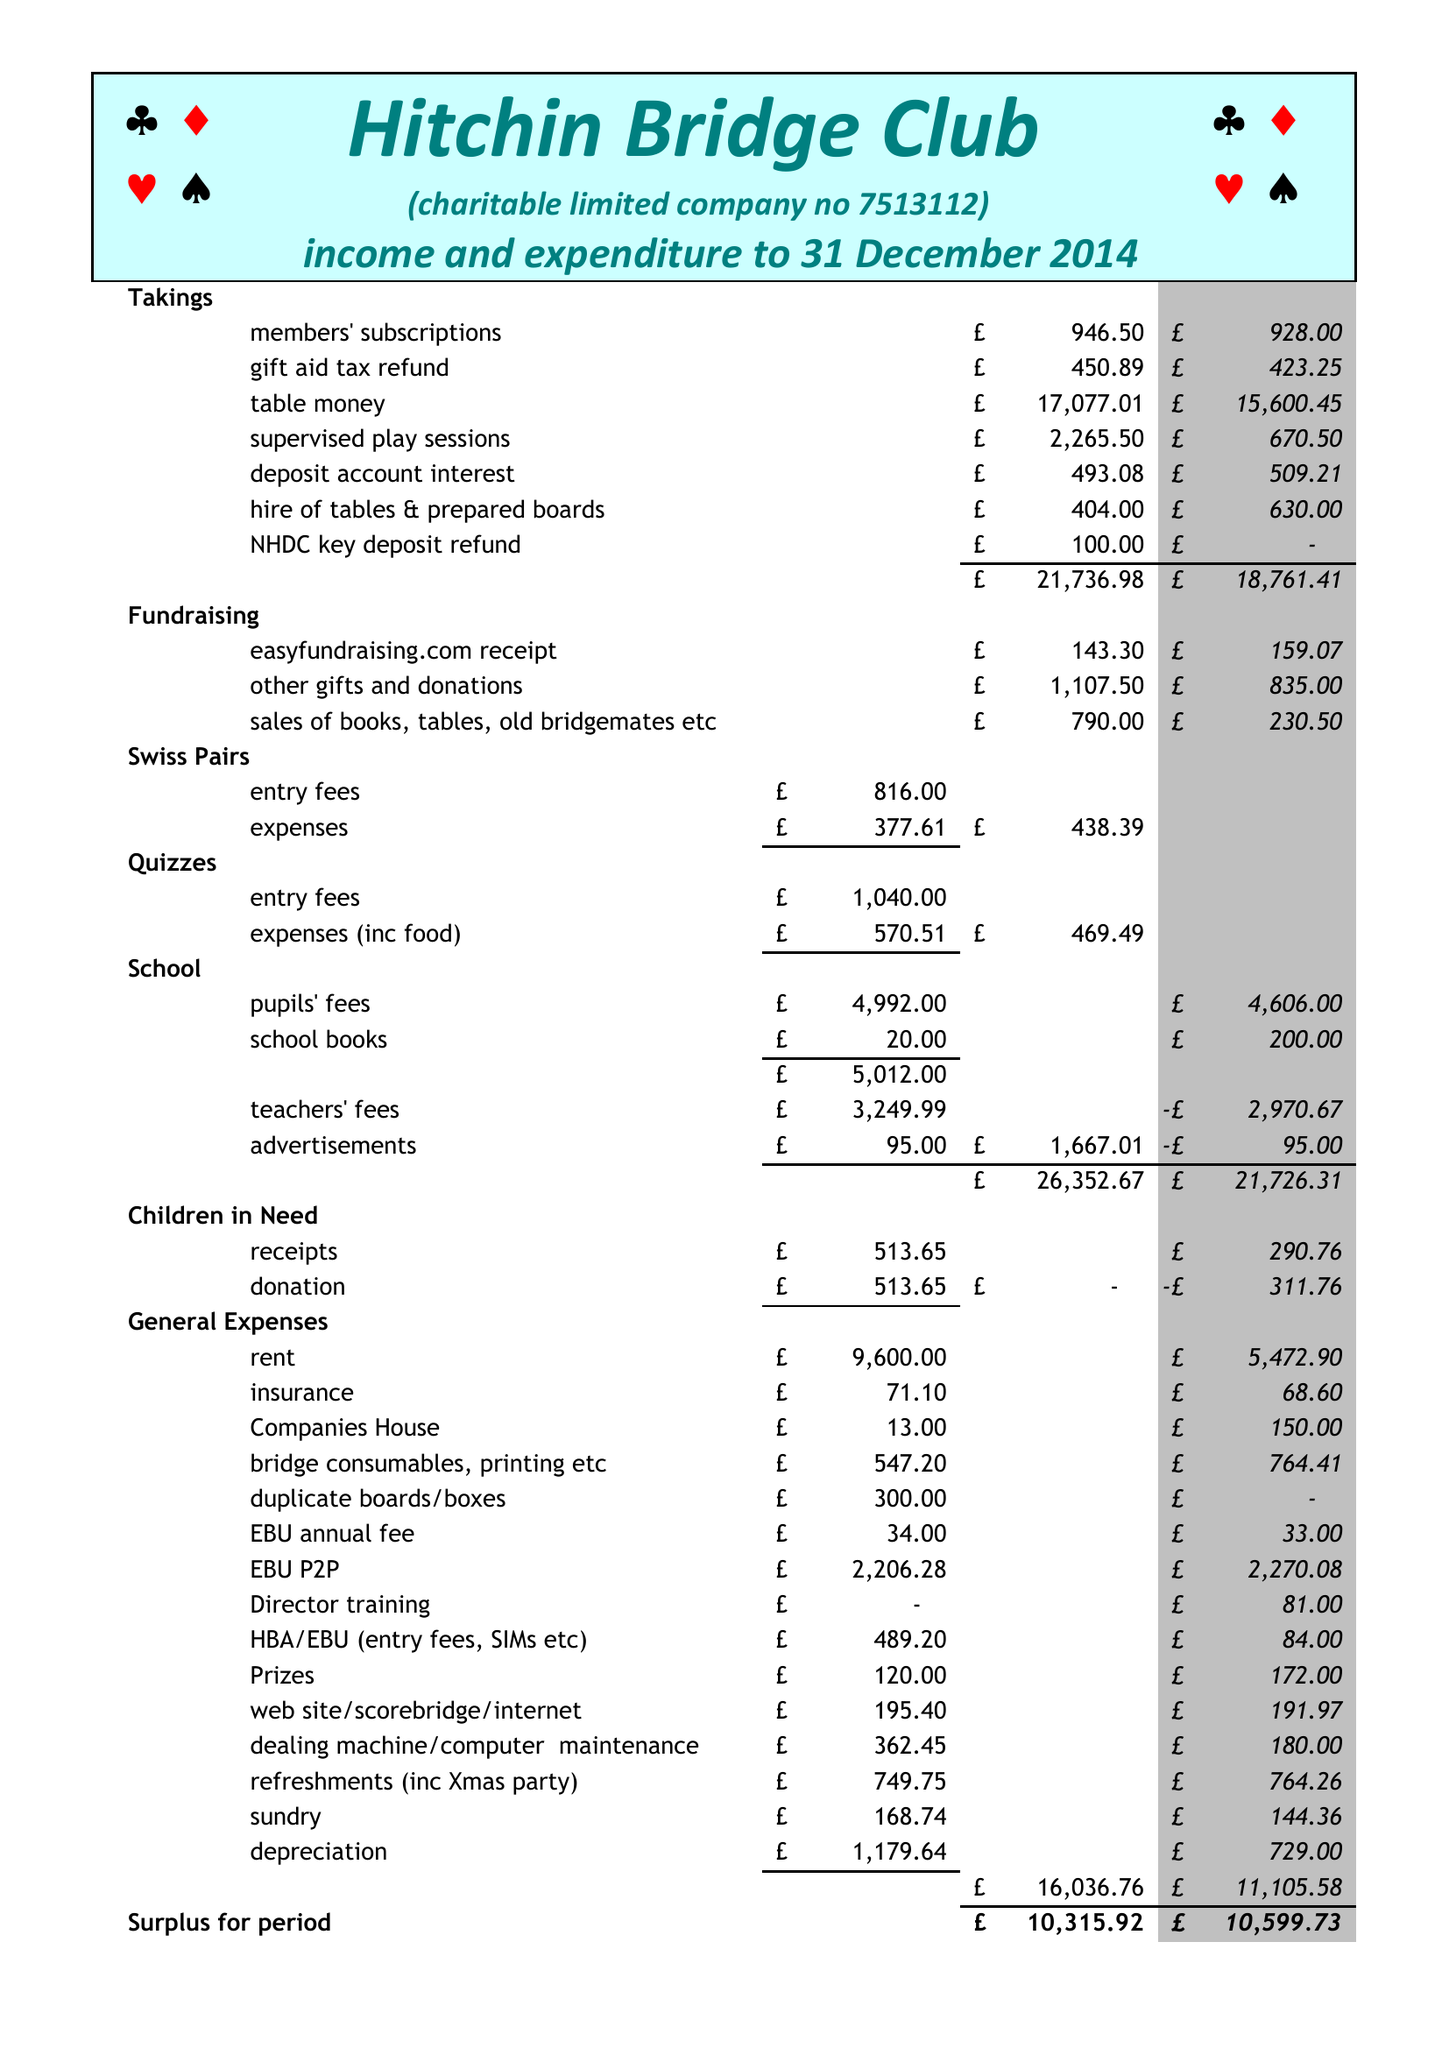What is the value for the report_date?
Answer the question using a single word or phrase. 2014-12-31 